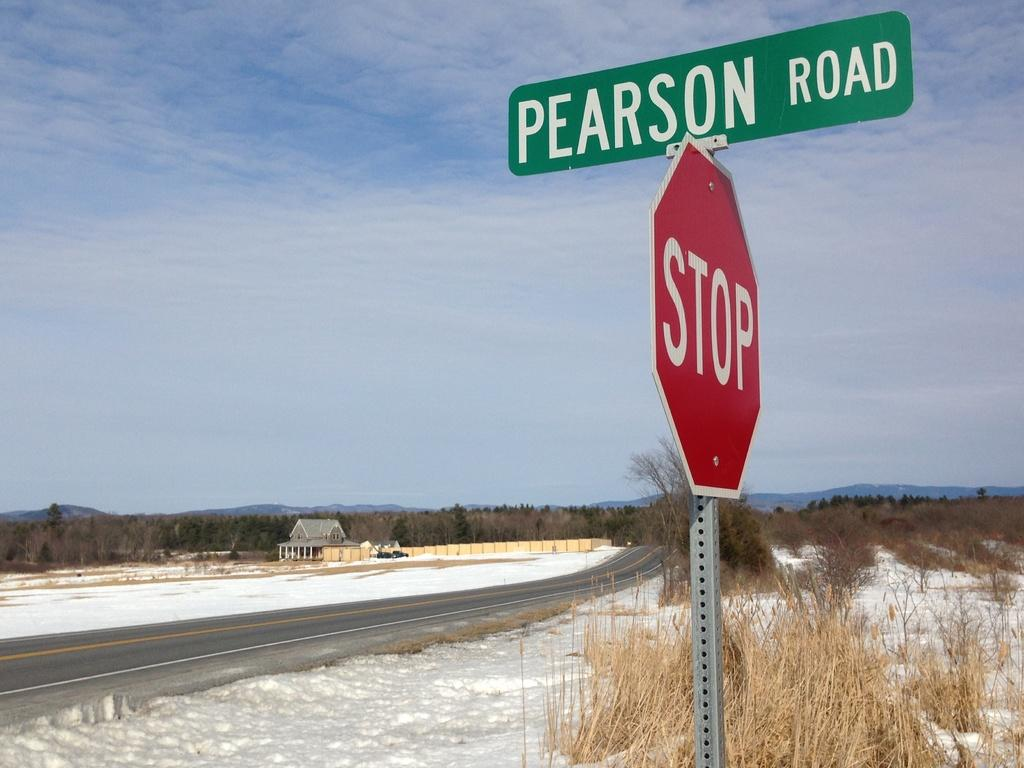<image>
Give a short and clear explanation of the subsequent image. A stop sign stands at the corner of Pearson Road. 